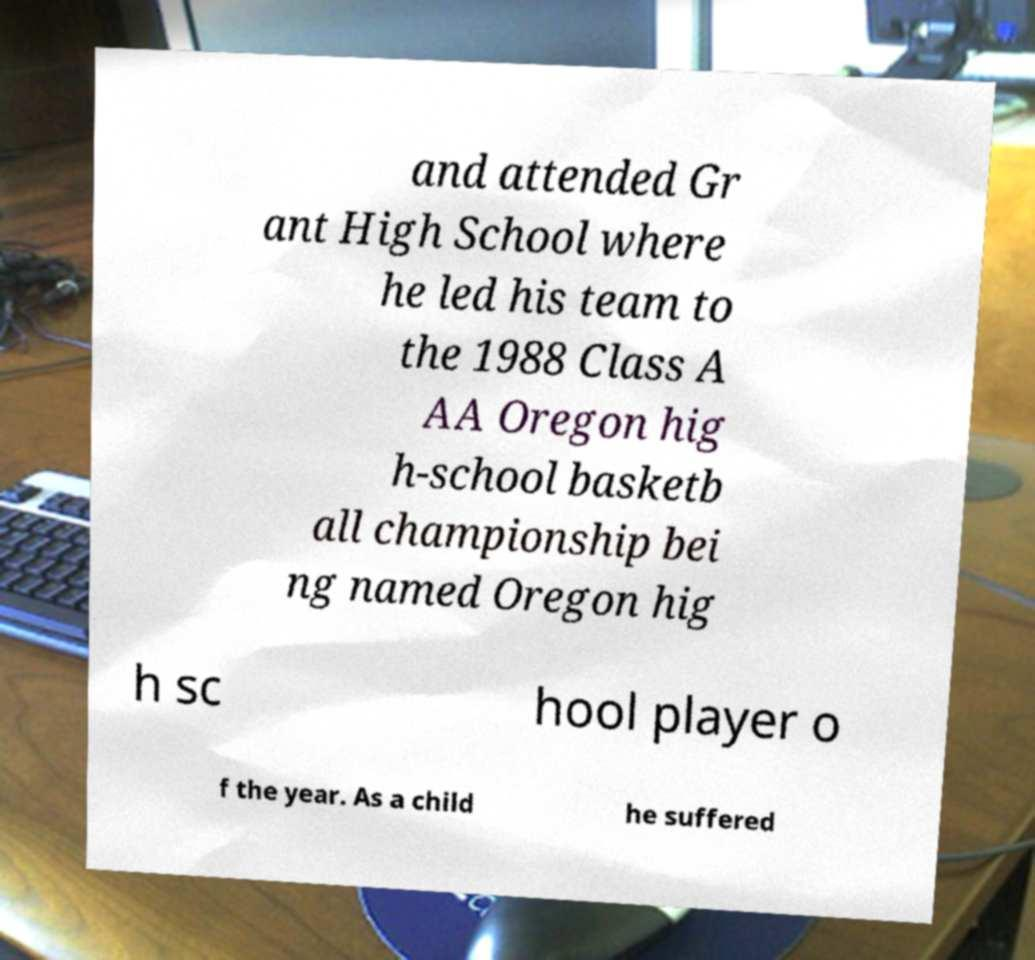Can you read and provide the text displayed in the image?This photo seems to have some interesting text. Can you extract and type it out for me? and attended Gr ant High School where he led his team to the 1988 Class A AA Oregon hig h-school basketb all championship bei ng named Oregon hig h sc hool player o f the year. As a child he suffered 